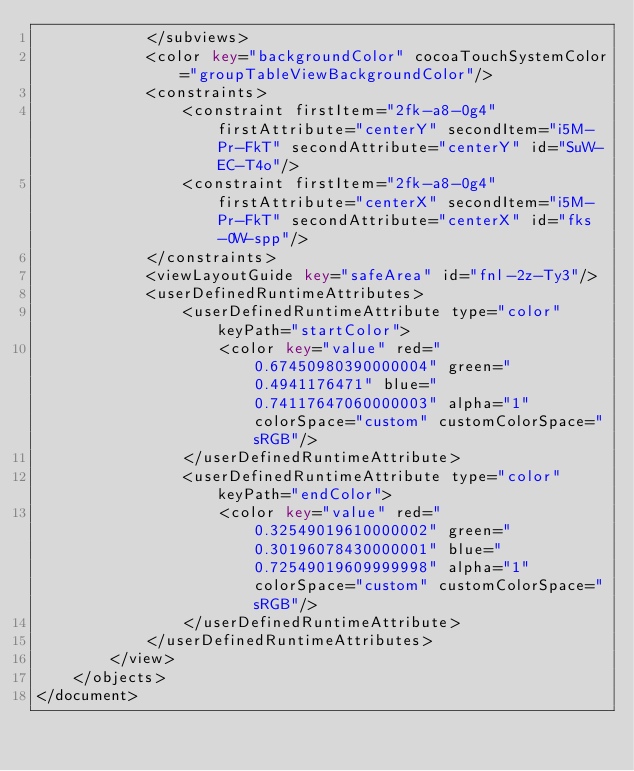<code> <loc_0><loc_0><loc_500><loc_500><_XML_>            </subviews>
            <color key="backgroundColor" cocoaTouchSystemColor="groupTableViewBackgroundColor"/>
            <constraints>
                <constraint firstItem="2fk-a8-0g4" firstAttribute="centerY" secondItem="i5M-Pr-FkT" secondAttribute="centerY" id="SuW-EC-T4o"/>
                <constraint firstItem="2fk-a8-0g4" firstAttribute="centerX" secondItem="i5M-Pr-FkT" secondAttribute="centerX" id="fks-0W-spp"/>
            </constraints>
            <viewLayoutGuide key="safeArea" id="fnl-2z-Ty3"/>
            <userDefinedRuntimeAttributes>
                <userDefinedRuntimeAttribute type="color" keyPath="startColor">
                    <color key="value" red="0.67450980390000004" green="0.4941176471" blue="0.74117647060000003" alpha="1" colorSpace="custom" customColorSpace="sRGB"/>
                </userDefinedRuntimeAttribute>
                <userDefinedRuntimeAttribute type="color" keyPath="endColor">
                    <color key="value" red="0.32549019610000002" green="0.30196078430000001" blue="0.72549019609999998" alpha="1" colorSpace="custom" customColorSpace="sRGB"/>
                </userDefinedRuntimeAttribute>
            </userDefinedRuntimeAttributes>
        </view>
    </objects>
</document>
</code> 